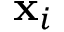<formula> <loc_0><loc_0><loc_500><loc_500>x _ { i }</formula> 